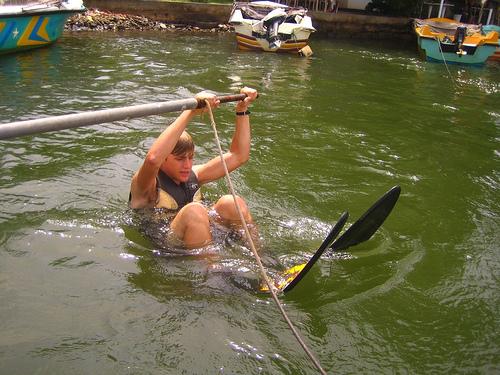Is the sinking?
Quick response, please. No. Is the water clear?
Concise answer only. No. Is the man wet?
Answer briefly. Yes. 